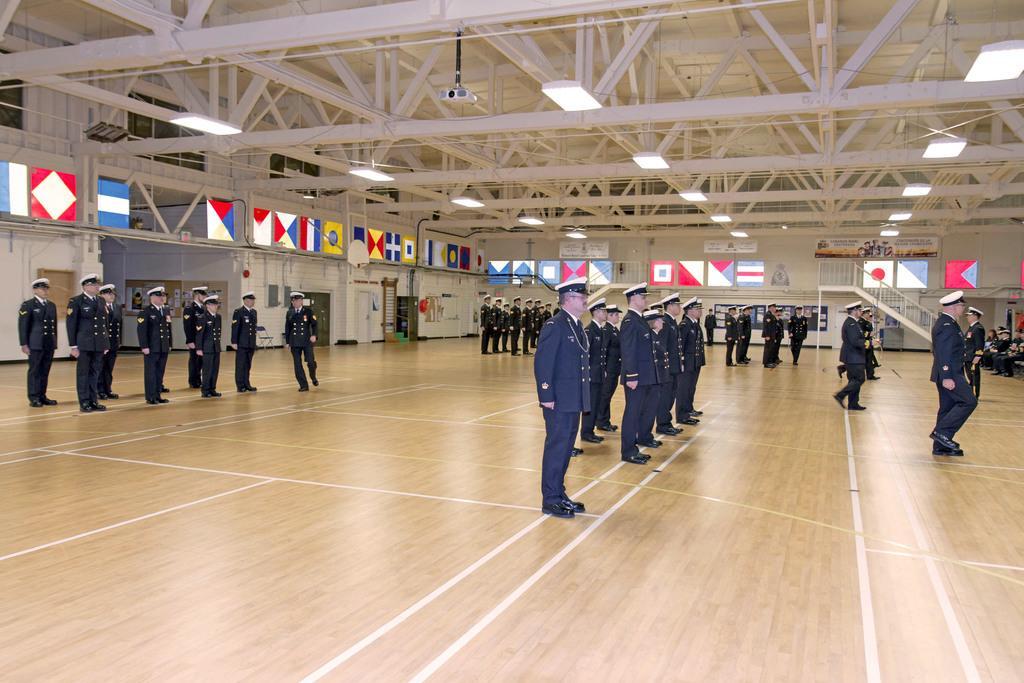How would you summarize this image in a sentence or two? In this image I can see people standing in a hall. They are wearing caps and uniforms. There are stairs and railing at the back. There are flags and lights at the top. 